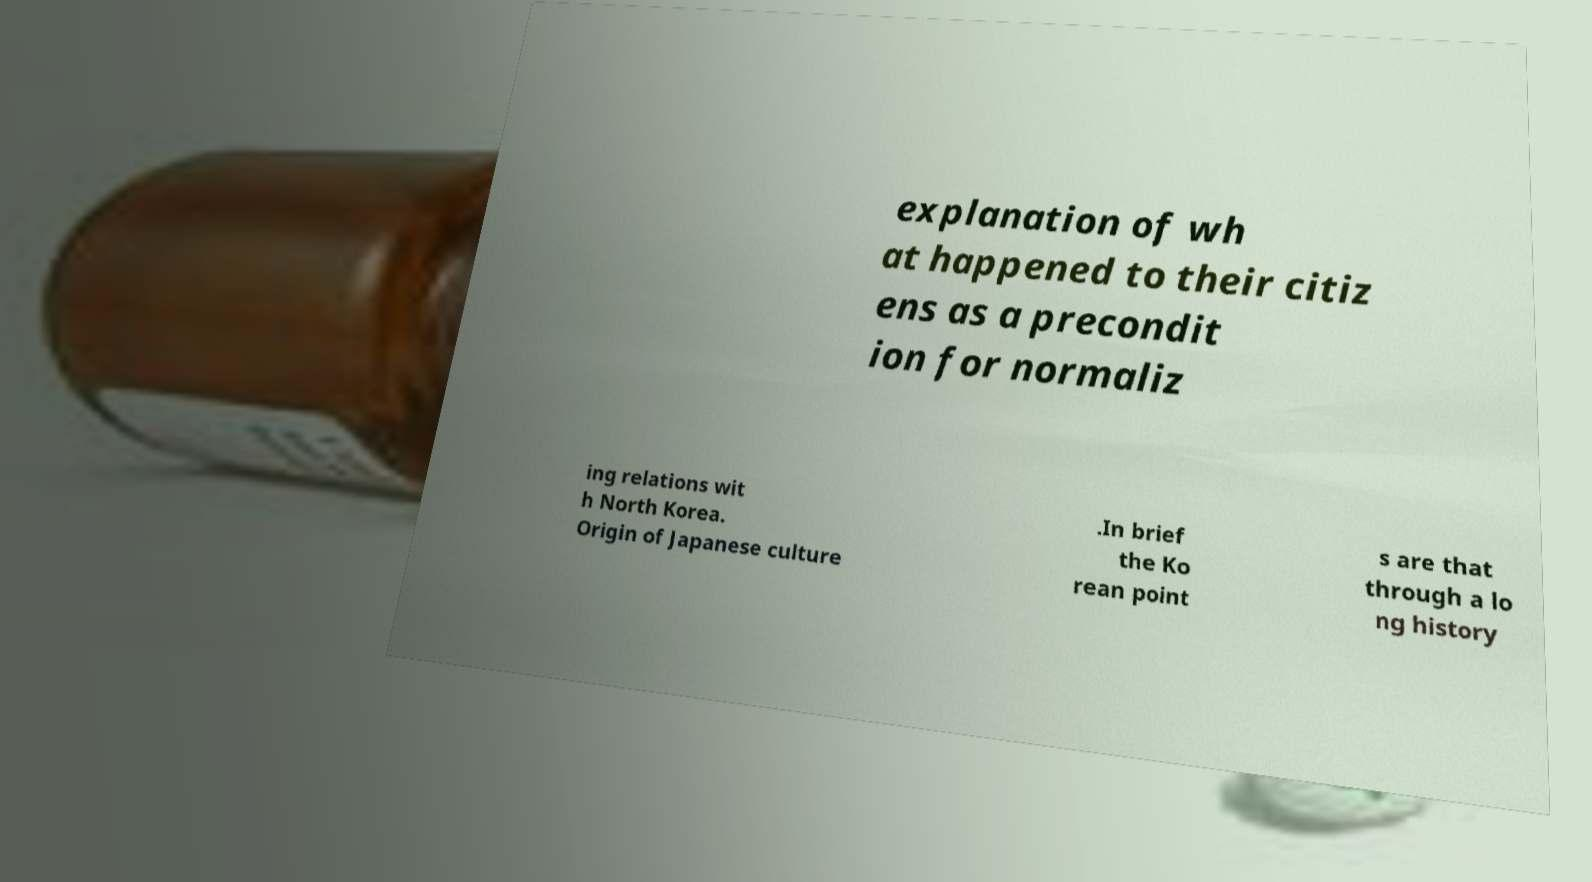What messages or text are displayed in this image? I need them in a readable, typed format. explanation of wh at happened to their citiz ens as a precondit ion for normaliz ing relations wit h North Korea. Origin of Japanese culture .In brief the Ko rean point s are that through a lo ng history 